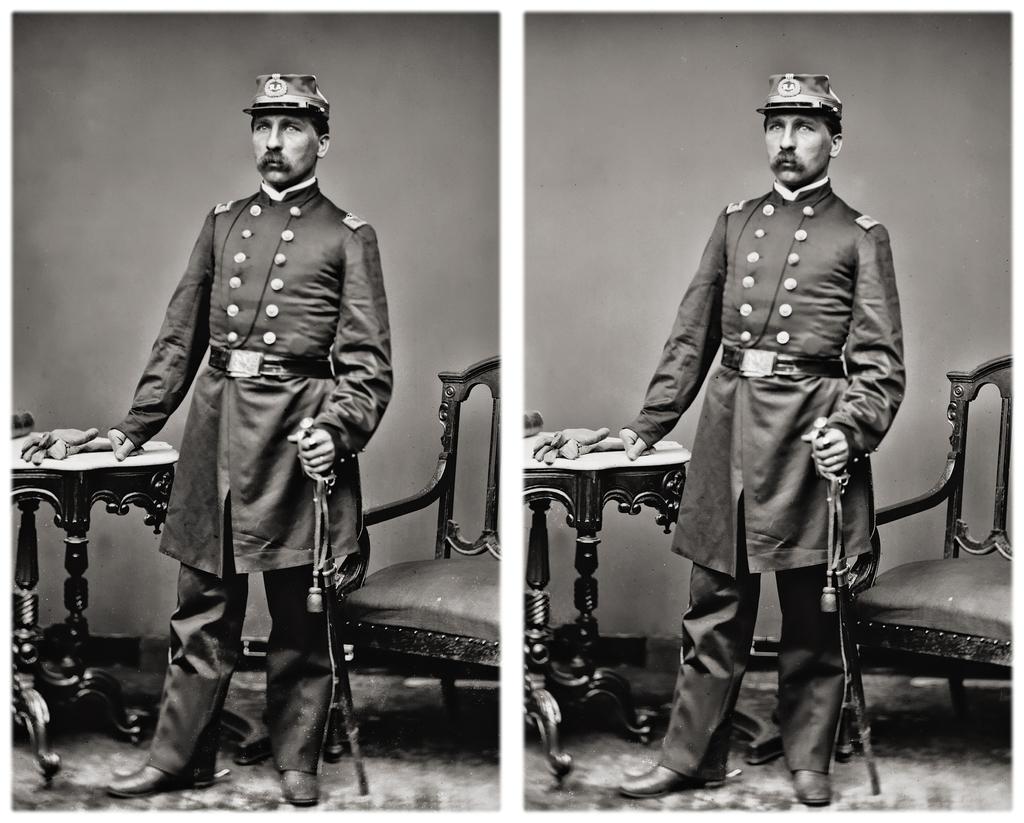In one or two sentences, can you explain what this image depicts? It is the collage image, there are two similar types of pictures kept one beside another and in the picture there is a man standing beside a child by keeping is one of the hand on a a stool and behind the man there is a wall and he is holding a weapon with his other hand. 